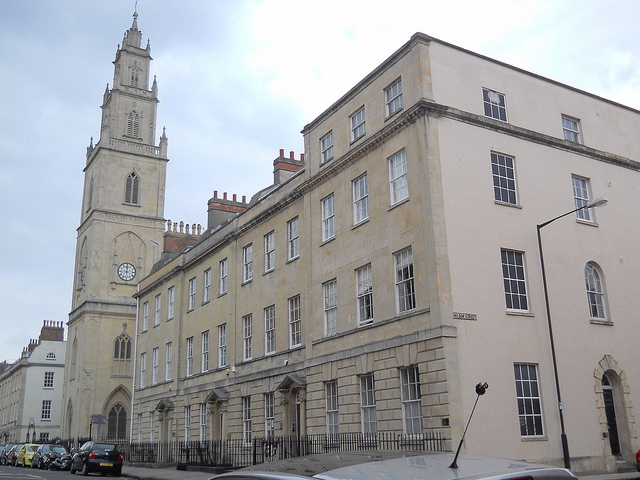What architectural style is the building in the image? The building in the image appears to be designed in the Georgian architectural style. This style is characterized by its symmetrical structure, sash windows, and classic proportions. These buildings often feature elaborate cornices and multi-paned windows, reflecting the elegance of 18th-century architecture. 